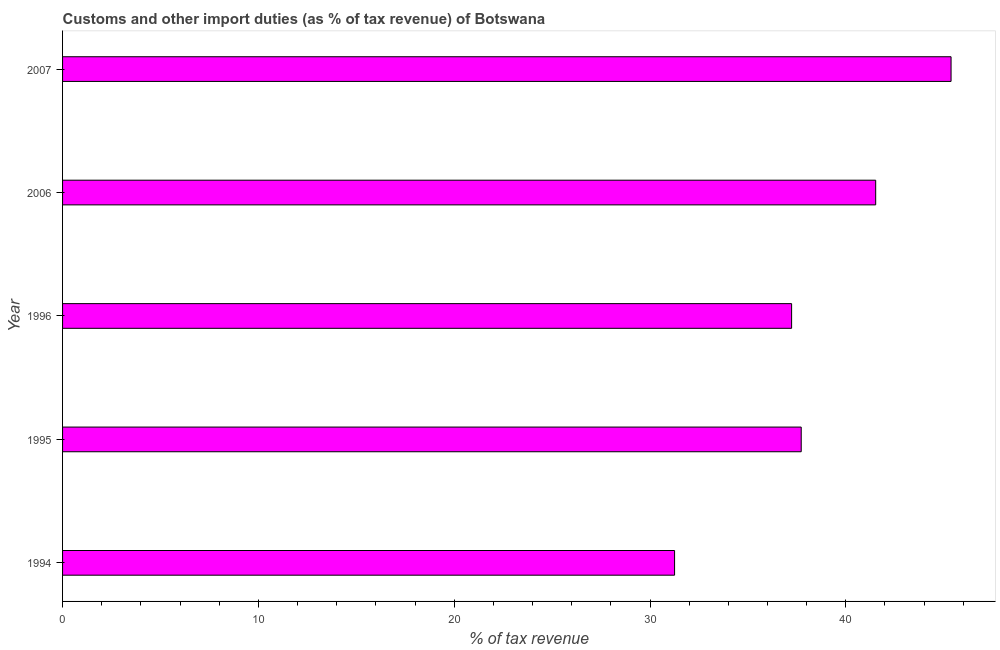What is the title of the graph?
Your answer should be very brief. Customs and other import duties (as % of tax revenue) of Botswana. What is the label or title of the X-axis?
Your answer should be very brief. % of tax revenue. What is the label or title of the Y-axis?
Provide a short and direct response. Year. What is the customs and other import duties in 2007?
Your response must be concise. 45.37. Across all years, what is the maximum customs and other import duties?
Offer a very short reply. 45.37. Across all years, what is the minimum customs and other import duties?
Offer a very short reply. 31.25. What is the sum of the customs and other import duties?
Offer a terse response. 193.11. What is the difference between the customs and other import duties in 1995 and 2006?
Make the answer very short. -3.8. What is the average customs and other import duties per year?
Ensure brevity in your answer.  38.62. What is the median customs and other import duties?
Ensure brevity in your answer.  37.72. What is the ratio of the customs and other import duties in 1994 to that in 2006?
Offer a terse response. 0.75. Is the customs and other import duties in 1995 less than that in 2007?
Provide a succinct answer. Yes. What is the difference between the highest and the second highest customs and other import duties?
Provide a succinct answer. 3.85. Is the sum of the customs and other import duties in 1994 and 2006 greater than the maximum customs and other import duties across all years?
Your answer should be compact. Yes. What is the difference between the highest and the lowest customs and other import duties?
Provide a succinct answer. 14.12. In how many years, is the customs and other import duties greater than the average customs and other import duties taken over all years?
Your response must be concise. 2. How many years are there in the graph?
Provide a short and direct response. 5. What is the difference between two consecutive major ticks on the X-axis?
Give a very brief answer. 10. What is the % of tax revenue in 1994?
Make the answer very short. 31.25. What is the % of tax revenue in 1995?
Provide a succinct answer. 37.72. What is the % of tax revenue of 1996?
Ensure brevity in your answer.  37.23. What is the % of tax revenue of 2006?
Provide a succinct answer. 41.53. What is the % of tax revenue in 2007?
Provide a short and direct response. 45.37. What is the difference between the % of tax revenue in 1994 and 1995?
Give a very brief answer. -6.47. What is the difference between the % of tax revenue in 1994 and 1996?
Provide a succinct answer. -5.98. What is the difference between the % of tax revenue in 1994 and 2006?
Your response must be concise. -10.27. What is the difference between the % of tax revenue in 1994 and 2007?
Your answer should be compact. -14.12. What is the difference between the % of tax revenue in 1995 and 1996?
Ensure brevity in your answer.  0.49. What is the difference between the % of tax revenue in 1995 and 2006?
Your response must be concise. -3.8. What is the difference between the % of tax revenue in 1995 and 2007?
Your answer should be compact. -7.65. What is the difference between the % of tax revenue in 1996 and 2006?
Your answer should be very brief. -4.29. What is the difference between the % of tax revenue in 1996 and 2007?
Keep it short and to the point. -8.14. What is the difference between the % of tax revenue in 2006 and 2007?
Your response must be concise. -3.85. What is the ratio of the % of tax revenue in 1994 to that in 1995?
Provide a short and direct response. 0.83. What is the ratio of the % of tax revenue in 1994 to that in 1996?
Offer a very short reply. 0.84. What is the ratio of the % of tax revenue in 1994 to that in 2006?
Your answer should be very brief. 0.75. What is the ratio of the % of tax revenue in 1994 to that in 2007?
Offer a terse response. 0.69. What is the ratio of the % of tax revenue in 1995 to that in 2006?
Make the answer very short. 0.91. What is the ratio of the % of tax revenue in 1995 to that in 2007?
Your answer should be very brief. 0.83. What is the ratio of the % of tax revenue in 1996 to that in 2006?
Keep it short and to the point. 0.9. What is the ratio of the % of tax revenue in 1996 to that in 2007?
Your response must be concise. 0.82. What is the ratio of the % of tax revenue in 2006 to that in 2007?
Make the answer very short. 0.92. 